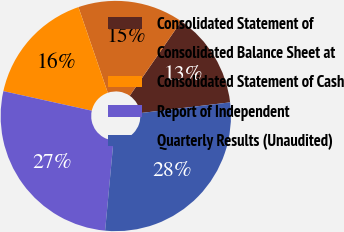Convert chart. <chart><loc_0><loc_0><loc_500><loc_500><pie_chart><fcel>Consolidated Statement of<fcel>Consolidated Balance Sheet at<fcel>Consolidated Statement of Cash<fcel>Report of Independent<fcel>Quarterly Results (Unaudited)<nl><fcel>13.49%<fcel>14.88%<fcel>16.27%<fcel>26.99%<fcel>28.37%<nl></chart> 